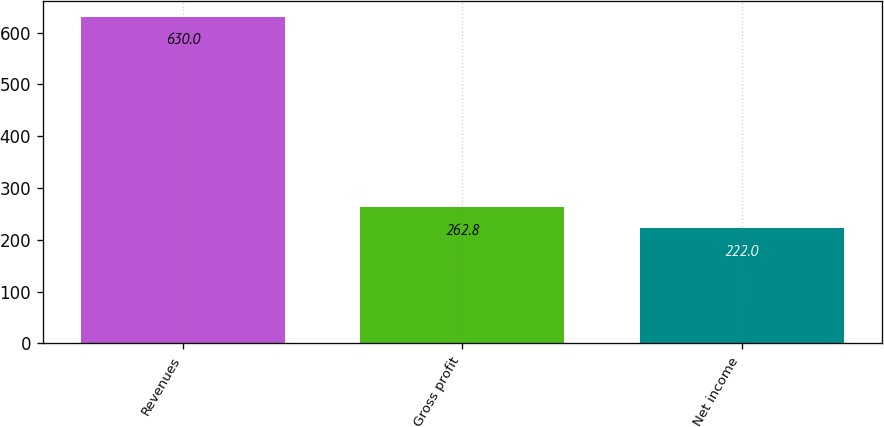Convert chart to OTSL. <chart><loc_0><loc_0><loc_500><loc_500><bar_chart><fcel>Revenues<fcel>Gross profit<fcel>Net income<nl><fcel>630<fcel>262.8<fcel>222<nl></chart> 